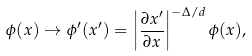Convert formula to latex. <formula><loc_0><loc_0><loc_500><loc_500>\phi ( x ) \rightarrow \phi ^ { \prime } ( x ^ { \prime } ) = \left | \frac { \partial x ^ { \prime } } { \partial x } \right | ^ { - \Delta / d } \phi ( x ) ,</formula> 